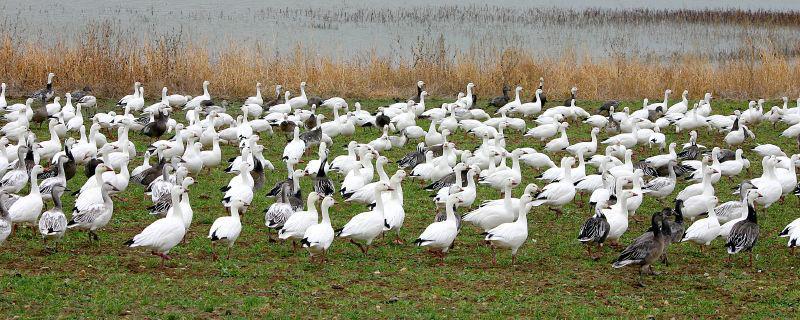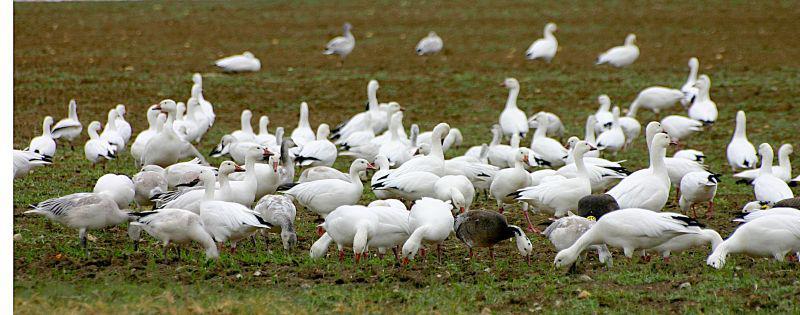The first image is the image on the left, the second image is the image on the right. For the images shown, is this caption "In at least one image, there are multiple birds in flight" true? Answer yes or no. No. The first image is the image on the left, the second image is the image on the right. Evaluate the accuracy of this statement regarding the images: "Someone is in the field with the animals.". Is it true? Answer yes or no. No. The first image is the image on the left, the second image is the image on the right. Analyze the images presented: Is the assertion "There is at least one person in one of the images." valid? Answer yes or no. No. The first image is the image on the left, the second image is the image on the right. Given the left and right images, does the statement "The birds in the image on the right are primarily white." hold true? Answer yes or no. Yes. 